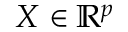<formula> <loc_0><loc_0><loc_500><loc_500>X \in \mathbb { R } ^ { p }</formula> 